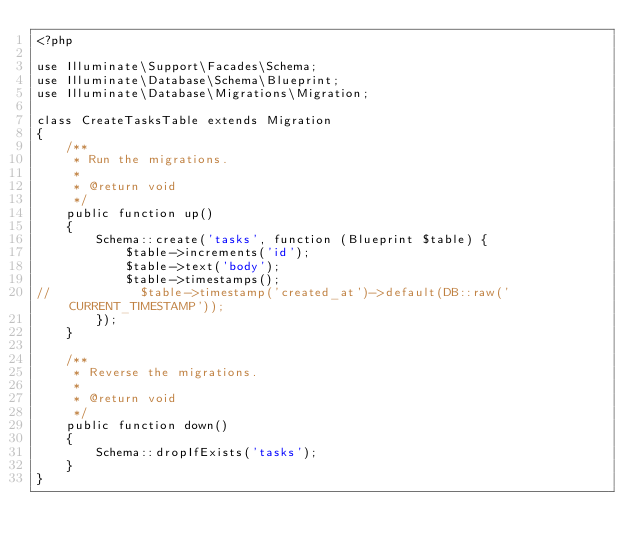Convert code to text. <code><loc_0><loc_0><loc_500><loc_500><_PHP_><?php

use Illuminate\Support\Facades\Schema;
use Illuminate\Database\Schema\Blueprint;
use Illuminate\Database\Migrations\Migration;

class CreateTasksTable extends Migration
{
    /**
     * Run the migrations.
     *
     * @return void
     */
    public function up()
    {
        Schema::create('tasks', function (Blueprint $table) {
            $table->increments('id');
            $table->text('body');
            $table->timestamps();
//            $table->timestamp('created_at')->default(DB::raw('CURRENT_TIMESTAMP'));
        });
    }

    /**
     * Reverse the migrations.
     *
     * @return void
     */
    public function down()
    {
        Schema::dropIfExists('tasks');
    }
}
</code> 